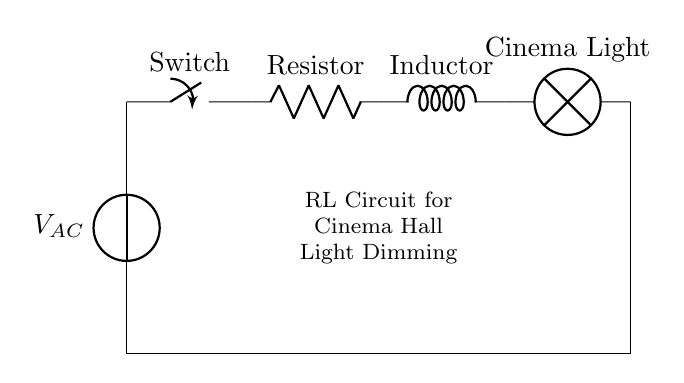What type of circuit is shown in the diagram? The diagram shows an RL circuit, which is characterized by the presence of a resistor and an inductor in series.
Answer: RL circuit What component is used to control the light intensity? The switch in the circuit is used to control the flow of current, thereby controlling the light intensity of the cinema light.
Answer: Switch What does the inductor do in this circuit? The inductor opposes changes in current, which allows for a gradual dimming effect when the switch is operated.
Answer: Gradual dimming What is connected in series with the resistor? The inductor is connected in series with the resistor, making it part of the same current path in the circuit.
Answer: Inductor How many main components are in this circuit? There are four main components: the voltage source, switch, resistor, and inductor.
Answer: Four What would happen if the switch is turned off? If the switch is turned off, the circuit would be open, and no current would flow, leading to the light turning off.
Answer: Light off What is the purpose of the resistor in this circuit? The resistor limits the current in the circuit, allowing for better control over the brightness of the cinema light.
Answer: Current limiting 